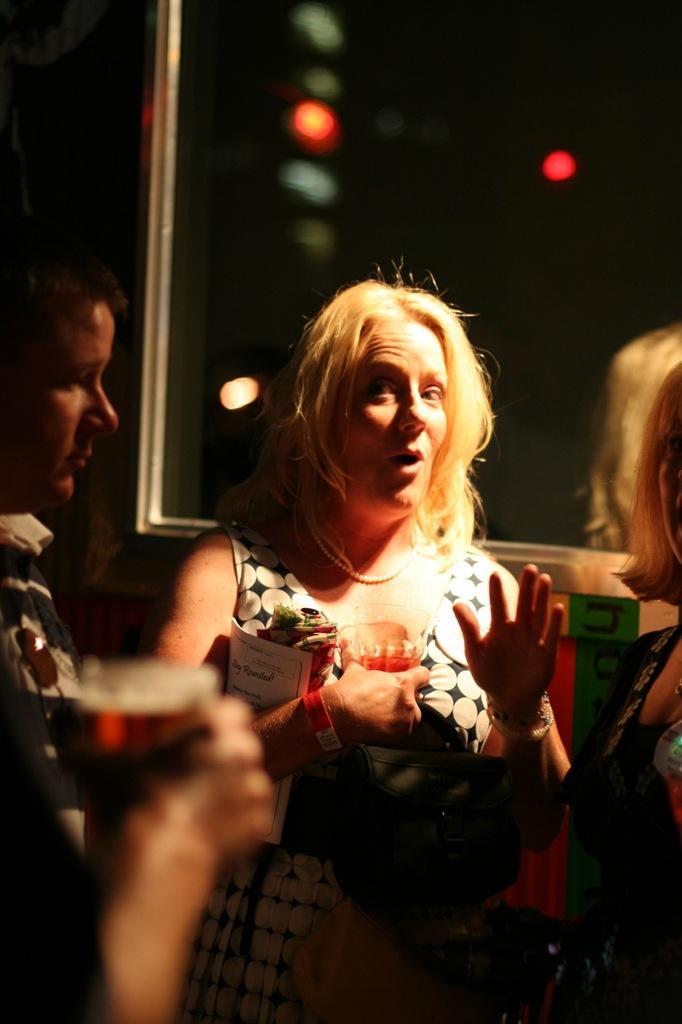Could you give a brief overview of what you see in this image? In this image there are people standing, in the background it is blurred. 